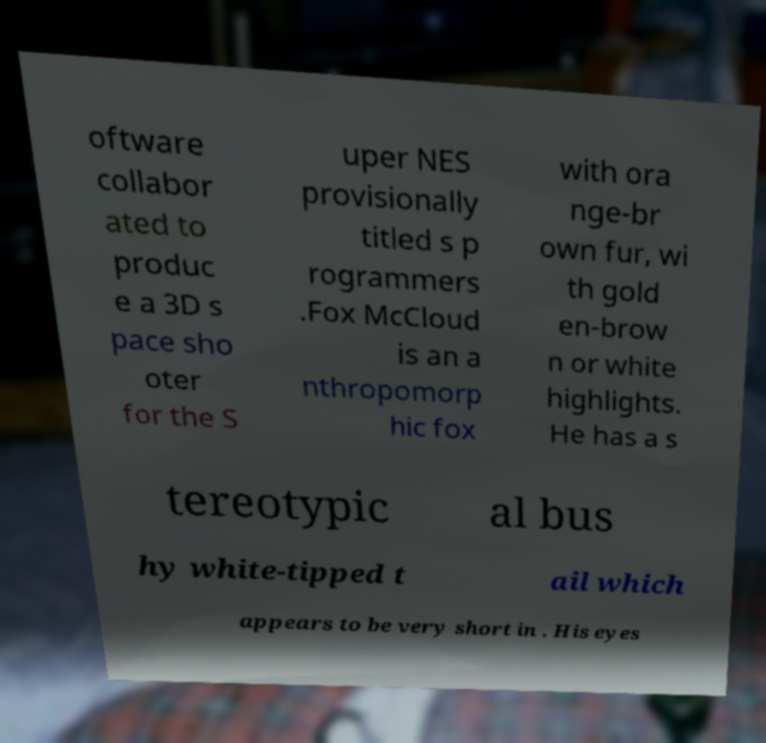Please read and relay the text visible in this image. What does it say? oftware collabor ated to produc e a 3D s pace sho oter for the S uper NES provisionally titled s p rogrammers .Fox McCloud is an a nthropomorp hic fox with ora nge-br own fur, wi th gold en-brow n or white highlights. He has a s tereotypic al bus hy white-tipped t ail which appears to be very short in . His eyes 